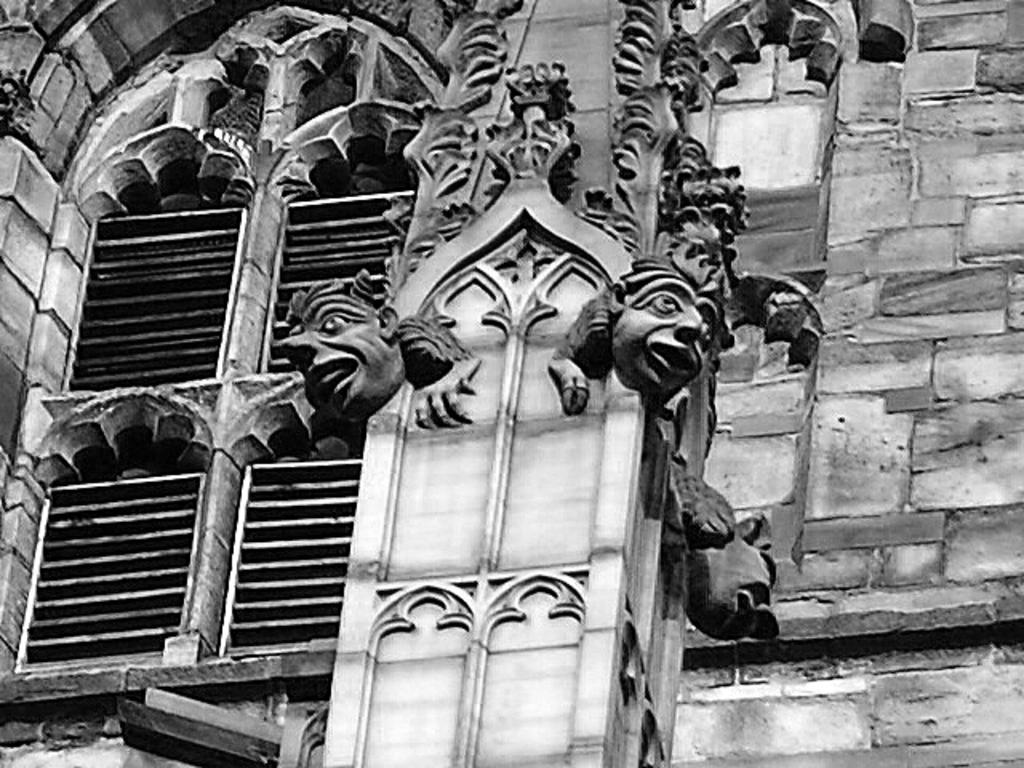What is the color scheme of the image? The image is black and white. What can be seen on the wall in the image? There is a wall with carvings in the image. Where is the window located in the image? The window is on the left side of the image. What type of meat is being cooked in the image? There is no meat or cooking activity present in the image; it features a wall with carvings and a black and white color scheme. 